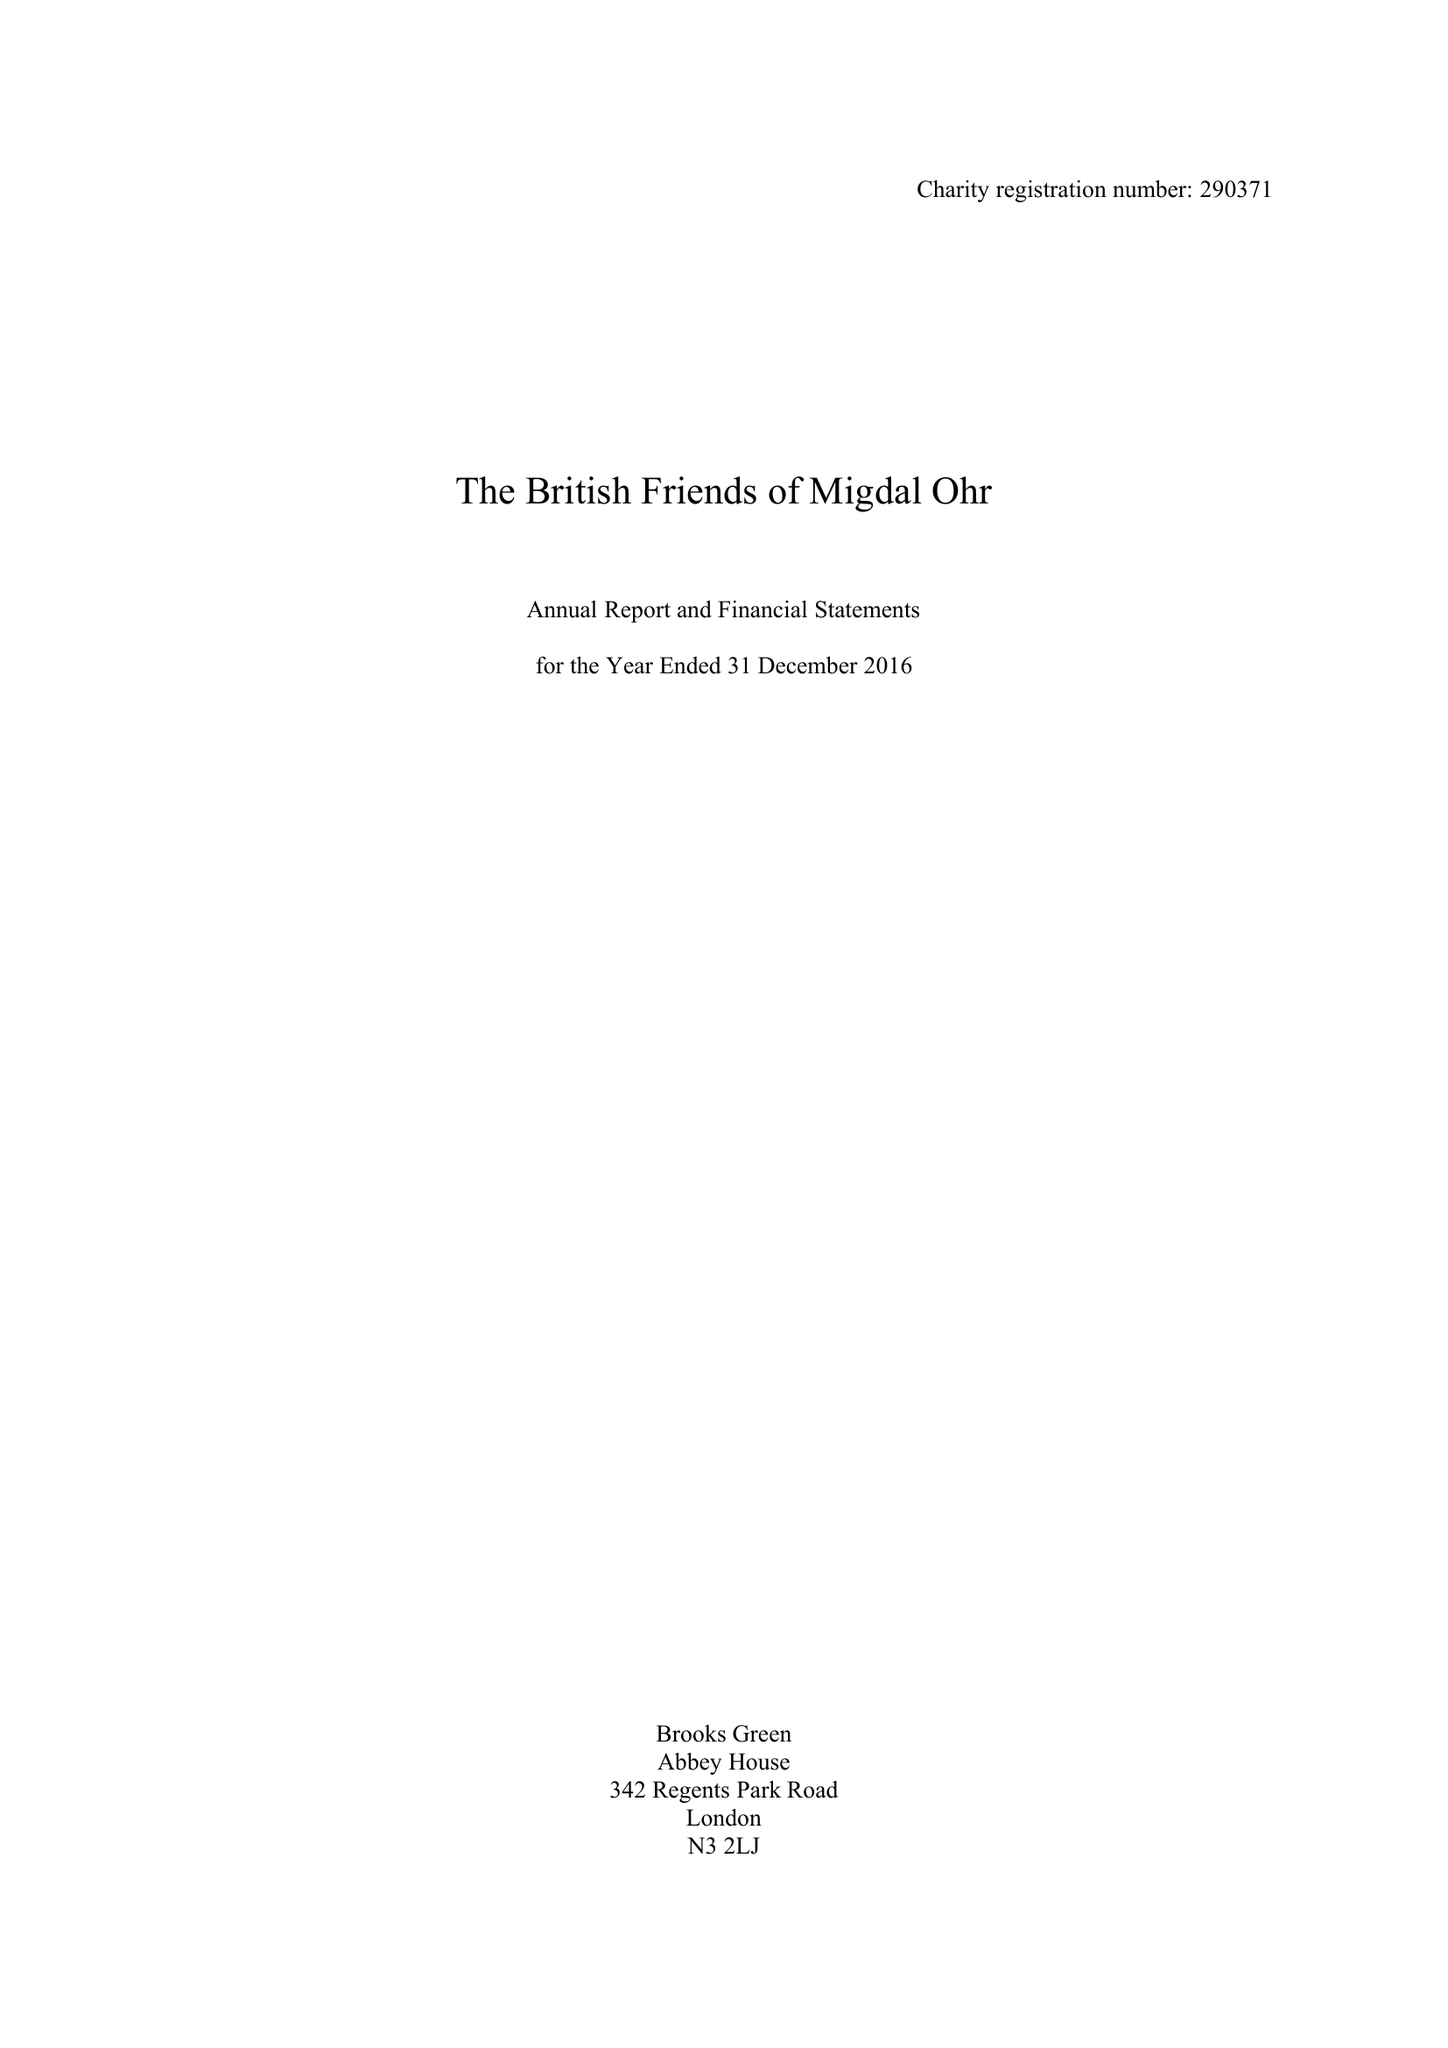What is the value for the address__street_line?
Answer the question using a single word or phrase. 4 FITZHARDINGE STREET 